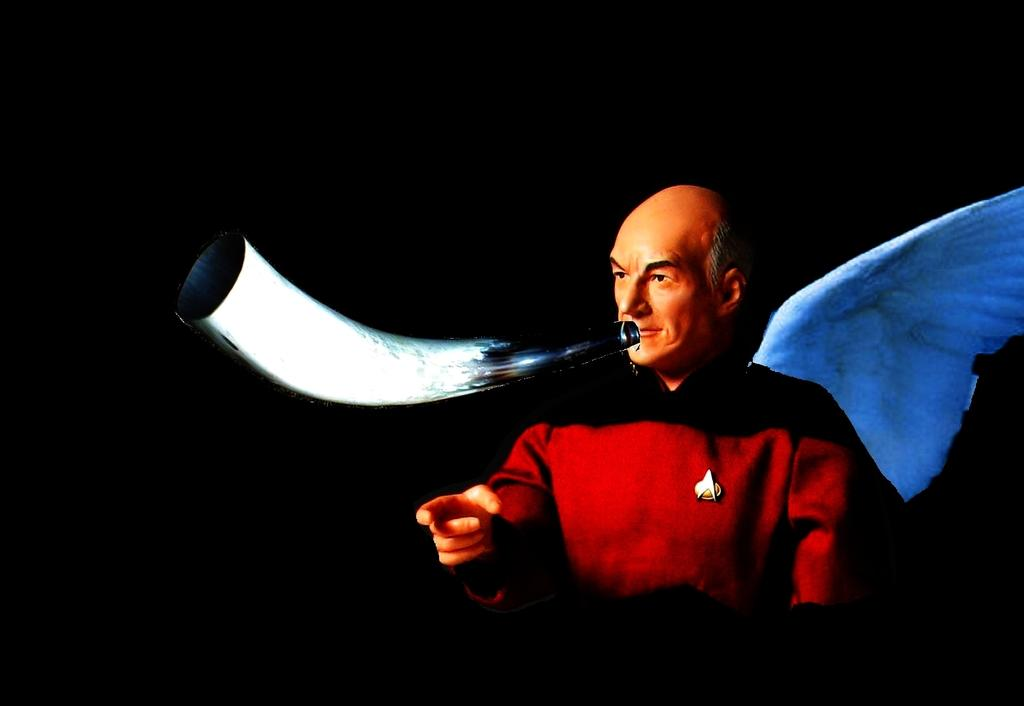What type of image is being described? The image is animated. Can you describe the person in the image? There is a person with a dress in the image. What colors are present in the objects in the image? There are black and white color objects in the image. What is the color of the background in the image? The background of the image is black. What type of pets can be seen in the image? There are no pets present in the image. What discovery was made by the person in the image? The image does not depict a discovery being made. What hobbies does the person in the image have? The image does not provide information about the person's hobbies. 